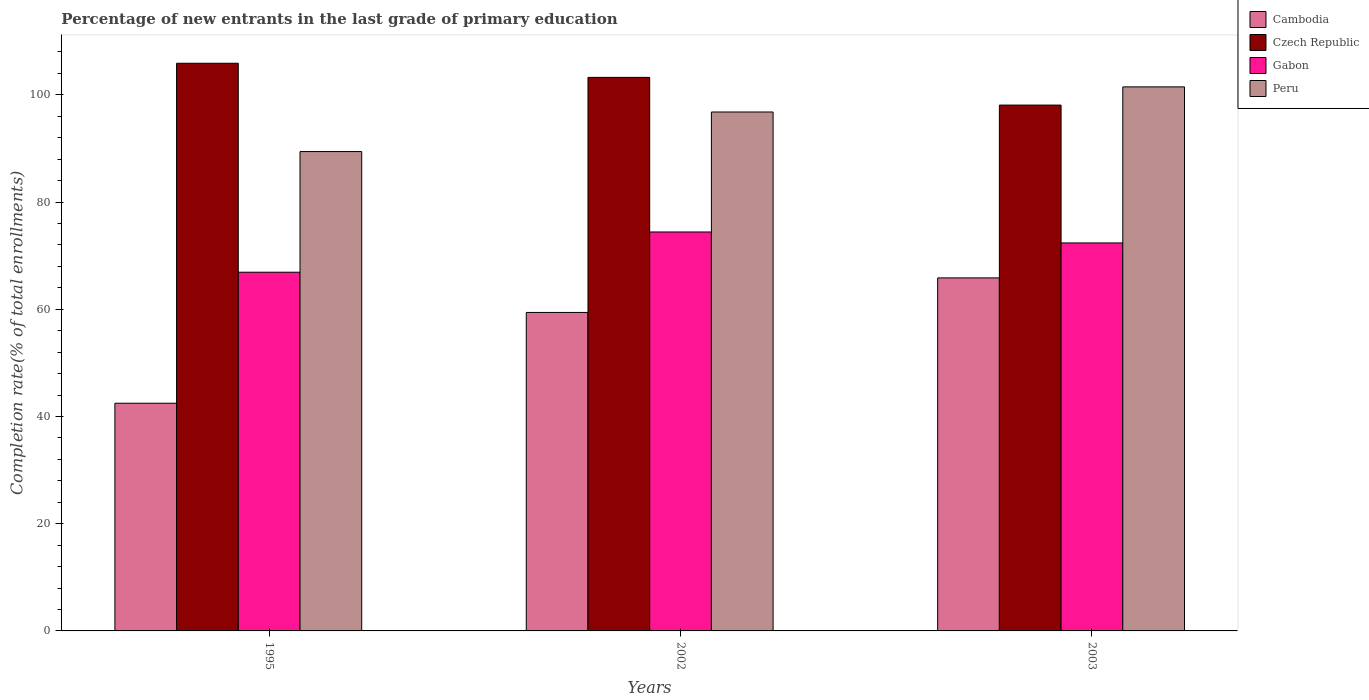How many groups of bars are there?
Provide a succinct answer. 3. How many bars are there on the 1st tick from the left?
Keep it short and to the point. 4. What is the label of the 3rd group of bars from the left?
Provide a short and direct response. 2003. In how many cases, is the number of bars for a given year not equal to the number of legend labels?
Provide a succinct answer. 0. What is the percentage of new entrants in Peru in 2002?
Offer a terse response. 96.81. Across all years, what is the maximum percentage of new entrants in Czech Republic?
Provide a succinct answer. 105.9. Across all years, what is the minimum percentage of new entrants in Czech Republic?
Offer a very short reply. 98.09. In which year was the percentage of new entrants in Peru maximum?
Provide a succinct answer. 2003. What is the total percentage of new entrants in Cambodia in the graph?
Keep it short and to the point. 167.75. What is the difference between the percentage of new entrants in Cambodia in 1995 and that in 2002?
Keep it short and to the point. -16.94. What is the difference between the percentage of new entrants in Cambodia in 2003 and the percentage of new entrants in Gabon in 2002?
Provide a succinct answer. -8.57. What is the average percentage of new entrants in Peru per year?
Give a very brief answer. 95.91. In the year 1995, what is the difference between the percentage of new entrants in Czech Republic and percentage of new entrants in Cambodia?
Make the answer very short. 63.42. What is the ratio of the percentage of new entrants in Czech Republic in 1995 to that in 2003?
Your response must be concise. 1.08. Is the percentage of new entrants in Czech Republic in 1995 less than that in 2003?
Offer a terse response. No. What is the difference between the highest and the second highest percentage of new entrants in Cambodia?
Offer a terse response. 6.44. What is the difference between the highest and the lowest percentage of new entrants in Peru?
Keep it short and to the point. 12.07. Is it the case that in every year, the sum of the percentage of new entrants in Cambodia and percentage of new entrants in Czech Republic is greater than the sum of percentage of new entrants in Gabon and percentage of new entrants in Peru?
Your answer should be compact. Yes. What does the 2nd bar from the left in 2003 represents?
Provide a succinct answer. Czech Republic. What is the difference between two consecutive major ticks on the Y-axis?
Ensure brevity in your answer.  20. Are the values on the major ticks of Y-axis written in scientific E-notation?
Offer a terse response. No. How many legend labels are there?
Offer a terse response. 4. What is the title of the graph?
Your response must be concise. Percentage of new entrants in the last grade of primary education. What is the label or title of the X-axis?
Your answer should be very brief. Years. What is the label or title of the Y-axis?
Give a very brief answer. Completion rate(% of total enrollments). What is the Completion rate(% of total enrollments) of Cambodia in 1995?
Provide a succinct answer. 42.48. What is the Completion rate(% of total enrollments) in Czech Republic in 1995?
Offer a very short reply. 105.9. What is the Completion rate(% of total enrollments) of Gabon in 1995?
Your response must be concise. 66.92. What is the Completion rate(% of total enrollments) of Peru in 1995?
Offer a terse response. 89.42. What is the Completion rate(% of total enrollments) of Cambodia in 2002?
Your answer should be compact. 59.41. What is the Completion rate(% of total enrollments) in Czech Republic in 2002?
Give a very brief answer. 103.26. What is the Completion rate(% of total enrollments) in Gabon in 2002?
Offer a terse response. 74.42. What is the Completion rate(% of total enrollments) of Peru in 2002?
Your answer should be compact. 96.81. What is the Completion rate(% of total enrollments) of Cambodia in 2003?
Your answer should be compact. 65.86. What is the Completion rate(% of total enrollments) of Czech Republic in 2003?
Your answer should be very brief. 98.09. What is the Completion rate(% of total enrollments) in Gabon in 2003?
Make the answer very short. 72.38. What is the Completion rate(% of total enrollments) in Peru in 2003?
Offer a terse response. 101.49. Across all years, what is the maximum Completion rate(% of total enrollments) of Cambodia?
Your response must be concise. 65.86. Across all years, what is the maximum Completion rate(% of total enrollments) of Czech Republic?
Offer a very short reply. 105.9. Across all years, what is the maximum Completion rate(% of total enrollments) of Gabon?
Make the answer very short. 74.42. Across all years, what is the maximum Completion rate(% of total enrollments) of Peru?
Provide a succinct answer. 101.49. Across all years, what is the minimum Completion rate(% of total enrollments) in Cambodia?
Your answer should be very brief. 42.48. Across all years, what is the minimum Completion rate(% of total enrollments) of Czech Republic?
Keep it short and to the point. 98.09. Across all years, what is the minimum Completion rate(% of total enrollments) of Gabon?
Provide a short and direct response. 66.92. Across all years, what is the minimum Completion rate(% of total enrollments) in Peru?
Offer a very short reply. 89.42. What is the total Completion rate(% of total enrollments) of Cambodia in the graph?
Offer a very short reply. 167.75. What is the total Completion rate(% of total enrollments) in Czech Republic in the graph?
Ensure brevity in your answer.  307.25. What is the total Completion rate(% of total enrollments) in Gabon in the graph?
Your answer should be very brief. 213.72. What is the total Completion rate(% of total enrollments) in Peru in the graph?
Keep it short and to the point. 287.72. What is the difference between the Completion rate(% of total enrollments) of Cambodia in 1995 and that in 2002?
Your answer should be very brief. -16.94. What is the difference between the Completion rate(% of total enrollments) of Czech Republic in 1995 and that in 2002?
Offer a very short reply. 2.64. What is the difference between the Completion rate(% of total enrollments) of Gabon in 1995 and that in 2002?
Keep it short and to the point. -7.51. What is the difference between the Completion rate(% of total enrollments) of Peru in 1995 and that in 2002?
Offer a very short reply. -7.38. What is the difference between the Completion rate(% of total enrollments) of Cambodia in 1995 and that in 2003?
Your answer should be very brief. -23.38. What is the difference between the Completion rate(% of total enrollments) of Czech Republic in 1995 and that in 2003?
Keep it short and to the point. 7.8. What is the difference between the Completion rate(% of total enrollments) of Gabon in 1995 and that in 2003?
Your answer should be very brief. -5.46. What is the difference between the Completion rate(% of total enrollments) of Peru in 1995 and that in 2003?
Your answer should be compact. -12.07. What is the difference between the Completion rate(% of total enrollments) of Cambodia in 2002 and that in 2003?
Offer a very short reply. -6.44. What is the difference between the Completion rate(% of total enrollments) in Czech Republic in 2002 and that in 2003?
Make the answer very short. 5.17. What is the difference between the Completion rate(% of total enrollments) of Gabon in 2002 and that in 2003?
Your answer should be very brief. 2.05. What is the difference between the Completion rate(% of total enrollments) in Peru in 2002 and that in 2003?
Keep it short and to the point. -4.68. What is the difference between the Completion rate(% of total enrollments) of Cambodia in 1995 and the Completion rate(% of total enrollments) of Czech Republic in 2002?
Your response must be concise. -60.78. What is the difference between the Completion rate(% of total enrollments) of Cambodia in 1995 and the Completion rate(% of total enrollments) of Gabon in 2002?
Keep it short and to the point. -31.95. What is the difference between the Completion rate(% of total enrollments) in Cambodia in 1995 and the Completion rate(% of total enrollments) in Peru in 2002?
Give a very brief answer. -54.33. What is the difference between the Completion rate(% of total enrollments) of Czech Republic in 1995 and the Completion rate(% of total enrollments) of Gabon in 2002?
Ensure brevity in your answer.  31.47. What is the difference between the Completion rate(% of total enrollments) of Czech Republic in 1995 and the Completion rate(% of total enrollments) of Peru in 2002?
Provide a succinct answer. 9.09. What is the difference between the Completion rate(% of total enrollments) of Gabon in 1995 and the Completion rate(% of total enrollments) of Peru in 2002?
Your answer should be very brief. -29.89. What is the difference between the Completion rate(% of total enrollments) in Cambodia in 1995 and the Completion rate(% of total enrollments) in Czech Republic in 2003?
Offer a terse response. -55.62. What is the difference between the Completion rate(% of total enrollments) of Cambodia in 1995 and the Completion rate(% of total enrollments) of Gabon in 2003?
Your response must be concise. -29.9. What is the difference between the Completion rate(% of total enrollments) in Cambodia in 1995 and the Completion rate(% of total enrollments) in Peru in 2003?
Offer a very short reply. -59.01. What is the difference between the Completion rate(% of total enrollments) of Czech Republic in 1995 and the Completion rate(% of total enrollments) of Gabon in 2003?
Keep it short and to the point. 33.52. What is the difference between the Completion rate(% of total enrollments) in Czech Republic in 1995 and the Completion rate(% of total enrollments) in Peru in 2003?
Offer a very short reply. 4.41. What is the difference between the Completion rate(% of total enrollments) of Gabon in 1995 and the Completion rate(% of total enrollments) of Peru in 2003?
Provide a succinct answer. -34.57. What is the difference between the Completion rate(% of total enrollments) in Cambodia in 2002 and the Completion rate(% of total enrollments) in Czech Republic in 2003?
Keep it short and to the point. -38.68. What is the difference between the Completion rate(% of total enrollments) of Cambodia in 2002 and the Completion rate(% of total enrollments) of Gabon in 2003?
Offer a terse response. -12.97. What is the difference between the Completion rate(% of total enrollments) in Cambodia in 2002 and the Completion rate(% of total enrollments) in Peru in 2003?
Your response must be concise. -42.08. What is the difference between the Completion rate(% of total enrollments) in Czech Republic in 2002 and the Completion rate(% of total enrollments) in Gabon in 2003?
Ensure brevity in your answer.  30.88. What is the difference between the Completion rate(% of total enrollments) in Czech Republic in 2002 and the Completion rate(% of total enrollments) in Peru in 2003?
Provide a succinct answer. 1.77. What is the difference between the Completion rate(% of total enrollments) in Gabon in 2002 and the Completion rate(% of total enrollments) in Peru in 2003?
Your answer should be very brief. -27.07. What is the average Completion rate(% of total enrollments) of Cambodia per year?
Your response must be concise. 55.92. What is the average Completion rate(% of total enrollments) of Czech Republic per year?
Ensure brevity in your answer.  102.42. What is the average Completion rate(% of total enrollments) of Gabon per year?
Keep it short and to the point. 71.24. What is the average Completion rate(% of total enrollments) in Peru per year?
Offer a very short reply. 95.91. In the year 1995, what is the difference between the Completion rate(% of total enrollments) of Cambodia and Completion rate(% of total enrollments) of Czech Republic?
Keep it short and to the point. -63.42. In the year 1995, what is the difference between the Completion rate(% of total enrollments) of Cambodia and Completion rate(% of total enrollments) of Gabon?
Keep it short and to the point. -24.44. In the year 1995, what is the difference between the Completion rate(% of total enrollments) of Cambodia and Completion rate(% of total enrollments) of Peru?
Offer a terse response. -46.95. In the year 1995, what is the difference between the Completion rate(% of total enrollments) of Czech Republic and Completion rate(% of total enrollments) of Gabon?
Your answer should be compact. 38.98. In the year 1995, what is the difference between the Completion rate(% of total enrollments) of Czech Republic and Completion rate(% of total enrollments) of Peru?
Offer a terse response. 16.47. In the year 1995, what is the difference between the Completion rate(% of total enrollments) of Gabon and Completion rate(% of total enrollments) of Peru?
Offer a very short reply. -22.51. In the year 2002, what is the difference between the Completion rate(% of total enrollments) of Cambodia and Completion rate(% of total enrollments) of Czech Republic?
Your response must be concise. -43.85. In the year 2002, what is the difference between the Completion rate(% of total enrollments) of Cambodia and Completion rate(% of total enrollments) of Gabon?
Give a very brief answer. -15.01. In the year 2002, what is the difference between the Completion rate(% of total enrollments) in Cambodia and Completion rate(% of total enrollments) in Peru?
Keep it short and to the point. -37.4. In the year 2002, what is the difference between the Completion rate(% of total enrollments) of Czech Republic and Completion rate(% of total enrollments) of Gabon?
Offer a terse response. 28.84. In the year 2002, what is the difference between the Completion rate(% of total enrollments) of Czech Republic and Completion rate(% of total enrollments) of Peru?
Make the answer very short. 6.45. In the year 2002, what is the difference between the Completion rate(% of total enrollments) of Gabon and Completion rate(% of total enrollments) of Peru?
Offer a terse response. -22.38. In the year 2003, what is the difference between the Completion rate(% of total enrollments) of Cambodia and Completion rate(% of total enrollments) of Czech Republic?
Keep it short and to the point. -32.24. In the year 2003, what is the difference between the Completion rate(% of total enrollments) of Cambodia and Completion rate(% of total enrollments) of Gabon?
Offer a terse response. -6.52. In the year 2003, what is the difference between the Completion rate(% of total enrollments) of Cambodia and Completion rate(% of total enrollments) of Peru?
Your answer should be very brief. -35.64. In the year 2003, what is the difference between the Completion rate(% of total enrollments) of Czech Republic and Completion rate(% of total enrollments) of Gabon?
Offer a terse response. 25.72. In the year 2003, what is the difference between the Completion rate(% of total enrollments) of Czech Republic and Completion rate(% of total enrollments) of Peru?
Ensure brevity in your answer.  -3.4. In the year 2003, what is the difference between the Completion rate(% of total enrollments) of Gabon and Completion rate(% of total enrollments) of Peru?
Keep it short and to the point. -29.11. What is the ratio of the Completion rate(% of total enrollments) of Cambodia in 1995 to that in 2002?
Your answer should be compact. 0.71. What is the ratio of the Completion rate(% of total enrollments) in Czech Republic in 1995 to that in 2002?
Your answer should be very brief. 1.03. What is the ratio of the Completion rate(% of total enrollments) of Gabon in 1995 to that in 2002?
Ensure brevity in your answer.  0.9. What is the ratio of the Completion rate(% of total enrollments) in Peru in 1995 to that in 2002?
Keep it short and to the point. 0.92. What is the ratio of the Completion rate(% of total enrollments) of Cambodia in 1995 to that in 2003?
Keep it short and to the point. 0.65. What is the ratio of the Completion rate(% of total enrollments) in Czech Republic in 1995 to that in 2003?
Provide a short and direct response. 1.08. What is the ratio of the Completion rate(% of total enrollments) in Gabon in 1995 to that in 2003?
Provide a short and direct response. 0.92. What is the ratio of the Completion rate(% of total enrollments) in Peru in 1995 to that in 2003?
Your answer should be compact. 0.88. What is the ratio of the Completion rate(% of total enrollments) in Cambodia in 2002 to that in 2003?
Your answer should be compact. 0.9. What is the ratio of the Completion rate(% of total enrollments) of Czech Republic in 2002 to that in 2003?
Offer a terse response. 1.05. What is the ratio of the Completion rate(% of total enrollments) of Gabon in 2002 to that in 2003?
Provide a short and direct response. 1.03. What is the ratio of the Completion rate(% of total enrollments) in Peru in 2002 to that in 2003?
Provide a short and direct response. 0.95. What is the difference between the highest and the second highest Completion rate(% of total enrollments) of Cambodia?
Provide a succinct answer. 6.44. What is the difference between the highest and the second highest Completion rate(% of total enrollments) in Czech Republic?
Offer a terse response. 2.64. What is the difference between the highest and the second highest Completion rate(% of total enrollments) in Gabon?
Make the answer very short. 2.05. What is the difference between the highest and the second highest Completion rate(% of total enrollments) of Peru?
Provide a succinct answer. 4.68. What is the difference between the highest and the lowest Completion rate(% of total enrollments) of Cambodia?
Make the answer very short. 23.38. What is the difference between the highest and the lowest Completion rate(% of total enrollments) in Czech Republic?
Provide a succinct answer. 7.8. What is the difference between the highest and the lowest Completion rate(% of total enrollments) in Gabon?
Provide a short and direct response. 7.51. What is the difference between the highest and the lowest Completion rate(% of total enrollments) in Peru?
Keep it short and to the point. 12.07. 